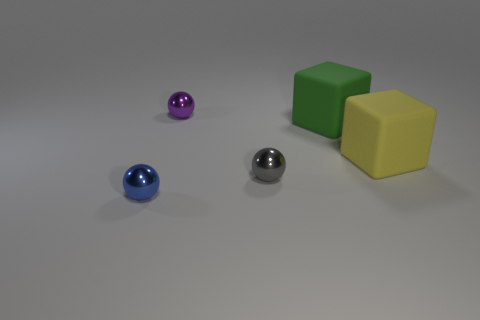There is a metal object that is in front of the tiny thing that is right of the metal object that is behind the gray object; what is its size?
Provide a succinct answer. Small. Is there any other thing that is the same shape as the yellow rubber thing?
Offer a terse response. Yes. What is the size of the blue metallic object in front of the cube to the right of the large green matte cube?
Make the answer very short. Small. What number of tiny things are cylinders or yellow blocks?
Offer a terse response. 0. Are there fewer large cyan rubber things than small gray spheres?
Provide a succinct answer. Yes. Are there any other things that have the same size as the gray sphere?
Keep it short and to the point. Yes. Are there more brown matte spheres than large cubes?
Offer a very short reply. No. There is a metallic sphere that is behind the yellow block; how many yellow matte objects are behind it?
Make the answer very short. 0. There is a small purple ball; are there any blue shiny things behind it?
Your answer should be very brief. No. What is the shape of the green thing that is in front of the tiny purple ball that is on the left side of the small gray ball?
Make the answer very short. Cube. 